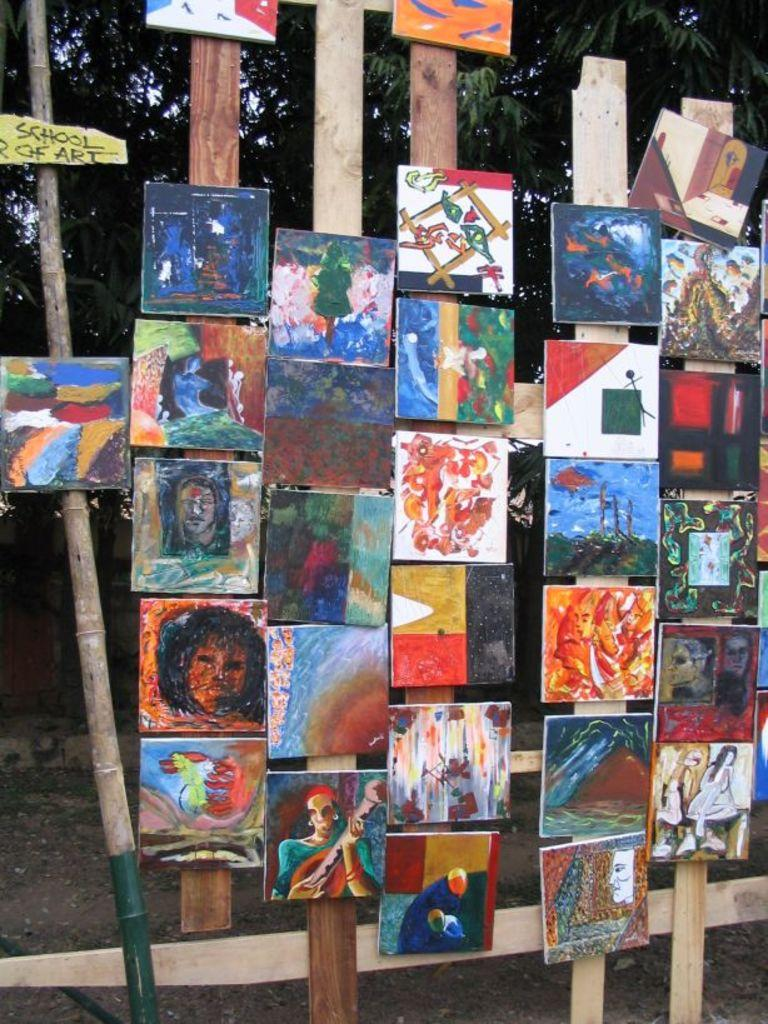What is the main subject of the image? The main subject of the image is a group of photo frames. What else can be seen in the image besides the photo frames? There is a tree and the ground visible in the image. What type of waves can be seen crashing against the shore in the image? There are no waves or shore visible in the image; it features a group of photo frames, a tree, and the ground. 